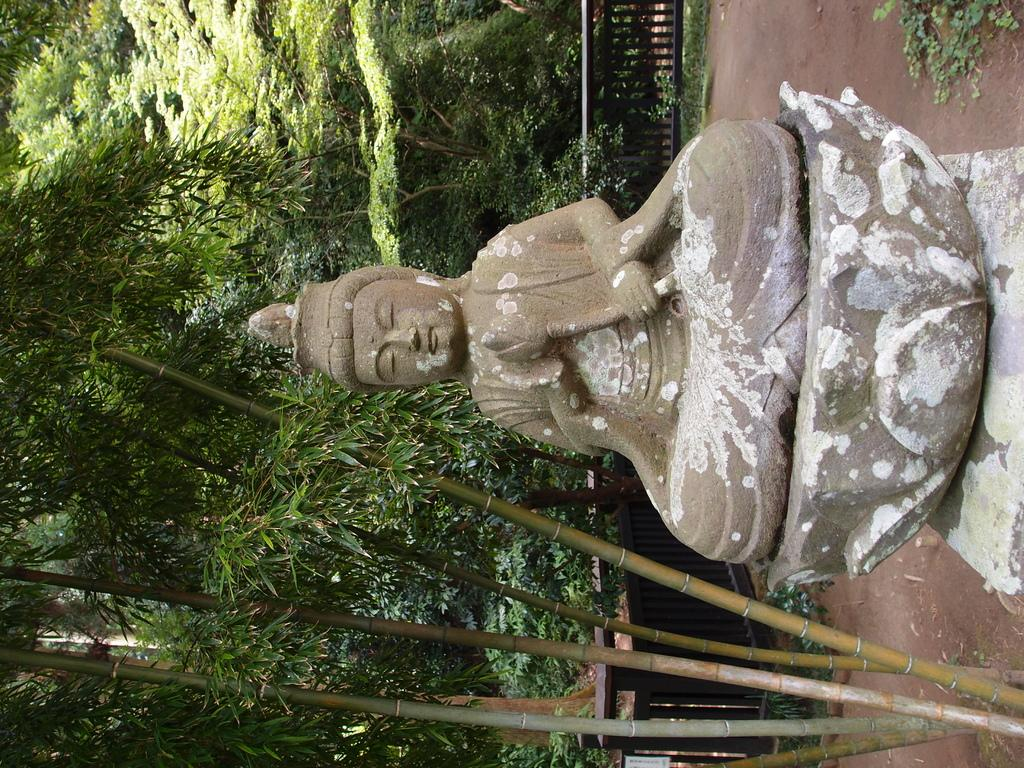What is located on the ground in the image? There is a statue on the ground in the image. What can be seen surrounding the statue? There is a fence in the image. What type of natural elements are visible in the background of the image? There are trees visible in the background of the image. What type of pencil can be seen in the image? There is no pencil present in the image. How does the alarm sound in the image? There is no alarm present in the image. 